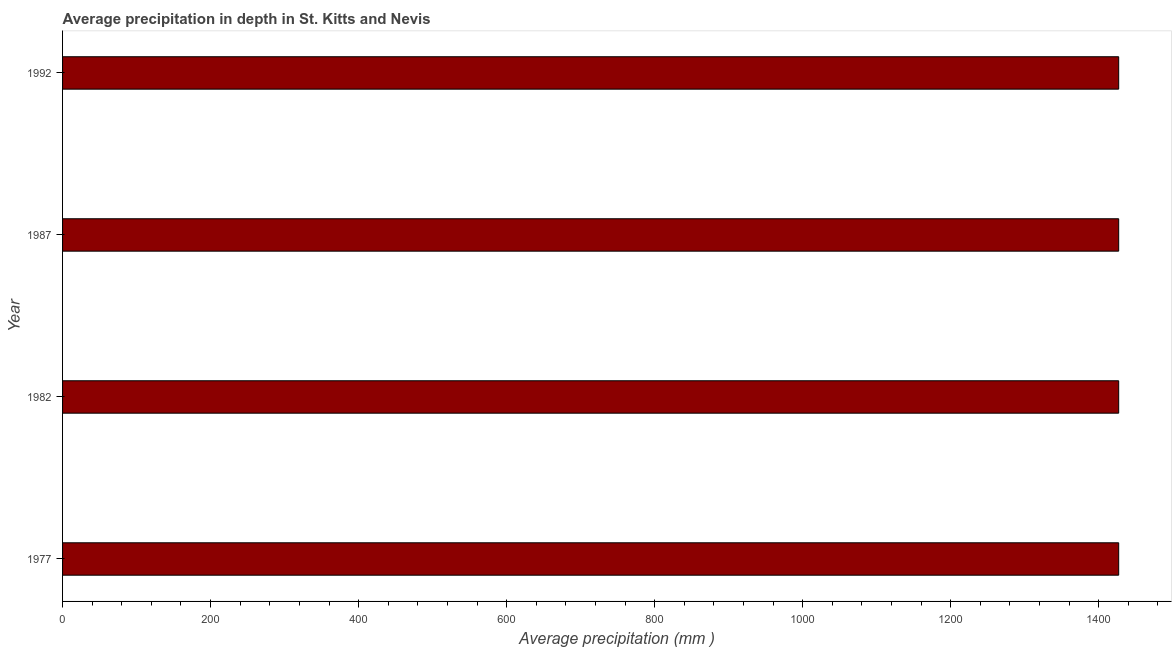Does the graph contain grids?
Provide a short and direct response. No. What is the title of the graph?
Offer a very short reply. Average precipitation in depth in St. Kitts and Nevis. What is the label or title of the X-axis?
Your response must be concise. Average precipitation (mm ). What is the label or title of the Y-axis?
Give a very brief answer. Year. What is the average precipitation in depth in 1977?
Provide a succinct answer. 1427. Across all years, what is the maximum average precipitation in depth?
Provide a short and direct response. 1427. Across all years, what is the minimum average precipitation in depth?
Your answer should be very brief. 1427. In which year was the average precipitation in depth maximum?
Your response must be concise. 1977. In which year was the average precipitation in depth minimum?
Provide a short and direct response. 1977. What is the sum of the average precipitation in depth?
Your response must be concise. 5708. What is the difference between the average precipitation in depth in 1977 and 1987?
Your answer should be compact. 0. What is the average average precipitation in depth per year?
Provide a succinct answer. 1427. What is the median average precipitation in depth?
Provide a succinct answer. 1427. In how many years, is the average precipitation in depth greater than 1240 mm?
Provide a succinct answer. 4. What is the ratio of the average precipitation in depth in 1982 to that in 1992?
Keep it short and to the point. 1. Is the average precipitation in depth in 1982 less than that in 1992?
Ensure brevity in your answer.  No. Is the difference between the average precipitation in depth in 1982 and 1992 greater than the difference between any two years?
Provide a short and direct response. Yes. What is the difference between the highest and the second highest average precipitation in depth?
Provide a succinct answer. 0. Is the sum of the average precipitation in depth in 1977 and 1992 greater than the maximum average precipitation in depth across all years?
Provide a succinct answer. Yes. What is the difference between the highest and the lowest average precipitation in depth?
Provide a succinct answer. 0. In how many years, is the average precipitation in depth greater than the average average precipitation in depth taken over all years?
Ensure brevity in your answer.  0. What is the difference between two consecutive major ticks on the X-axis?
Ensure brevity in your answer.  200. What is the Average precipitation (mm ) in 1977?
Ensure brevity in your answer.  1427. What is the Average precipitation (mm ) of 1982?
Offer a very short reply. 1427. What is the Average precipitation (mm ) of 1987?
Provide a short and direct response. 1427. What is the Average precipitation (mm ) of 1992?
Offer a terse response. 1427. What is the difference between the Average precipitation (mm ) in 1977 and 1982?
Offer a terse response. 0. What is the difference between the Average precipitation (mm ) in 1977 and 1987?
Your answer should be compact. 0. What is the difference between the Average precipitation (mm ) in 1982 and 1992?
Your answer should be compact. 0. What is the ratio of the Average precipitation (mm ) in 1977 to that in 1982?
Your answer should be very brief. 1. What is the ratio of the Average precipitation (mm ) in 1982 to that in 1987?
Provide a succinct answer. 1. 